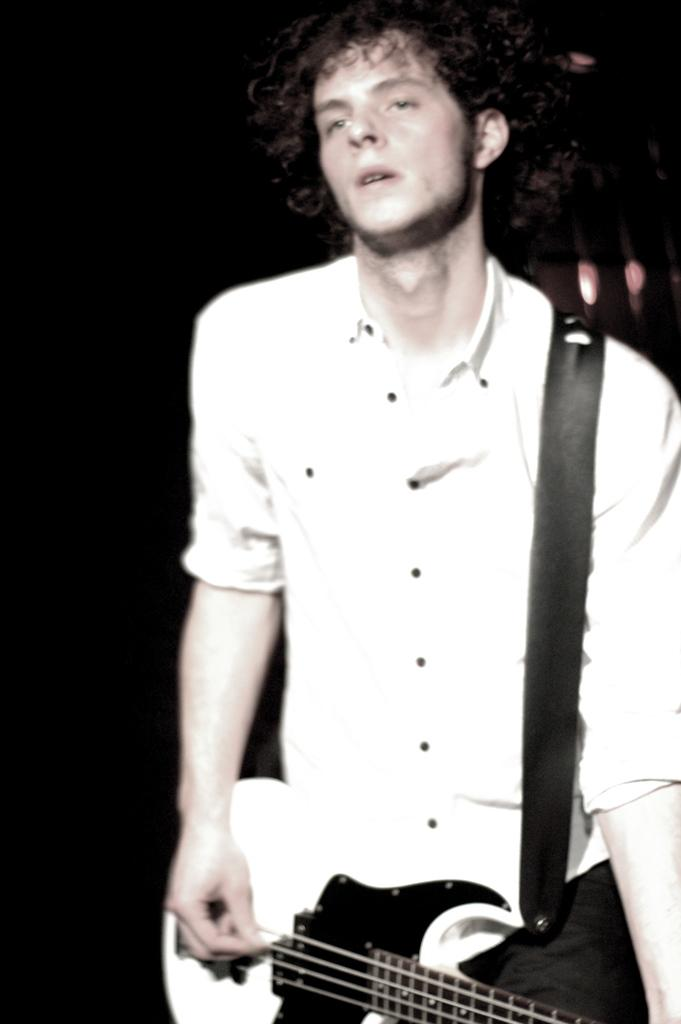What is the color of the background in the image? The background of the image is dark. Can you describe the person in the image? There is a man in the image, and he is playing a guitar. What is the man wearing? The man is wearing a white shirt. Can you describe the man's hair? The man has curly hair. Are there any giants attending the party in the image? There is no party or giants present in the image; it features a man playing a guitar with a dark background. What type of pail is being used to collect water in the image? There is no pail or water collection activity present in the image. 